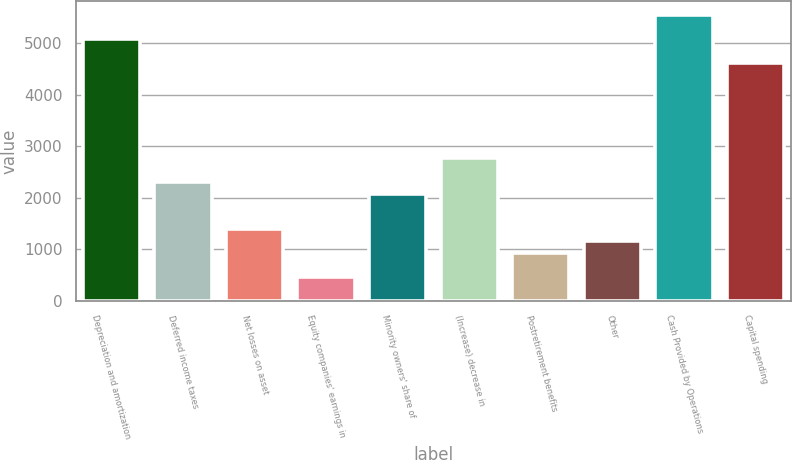Convert chart to OTSL. <chart><loc_0><loc_0><loc_500><loc_500><bar_chart><fcel>Depreciation and amortization<fcel>Deferred income taxes<fcel>Net losses on asset<fcel>Equity companies' earnings in<fcel>Minority owners' share of<fcel>(Increase) decrease in<fcel>Postretirement benefits<fcel>Other<fcel>Cash Provided by Operations<fcel>Capital spending<nl><fcel>5083.56<fcel>2311.8<fcel>1387.88<fcel>463.96<fcel>2080.82<fcel>2773.76<fcel>925.92<fcel>1156.9<fcel>5545.52<fcel>4621.6<nl></chart> 